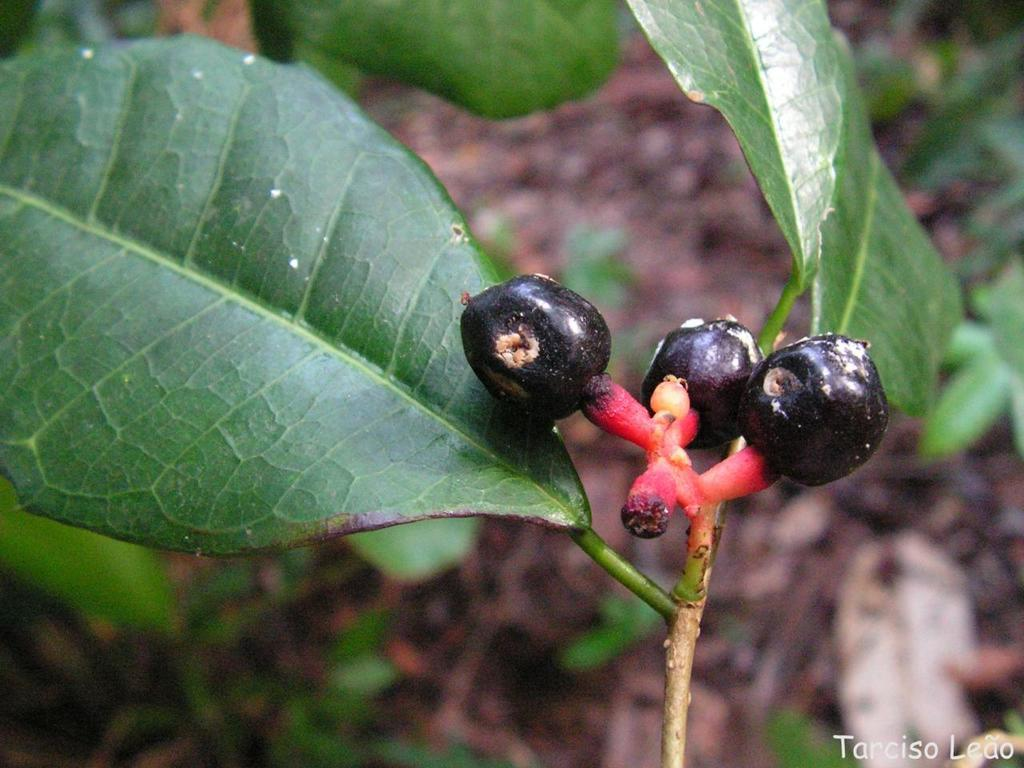What type of food items can be seen in the image? There are fruits in the image. What part of the fruit is visible in the image? There is a stem in the image. What other part of the plant is visible in the image? There is a leaf in the image. Is there any text or marking in the image? Yes, there is a watermark in the bottom right corner of the image. Can you see the doll breathing in the image? There is no doll present in the image, so it is not possible to see it breathing. 